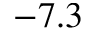<formula> <loc_0><loc_0><loc_500><loc_500>- 7 . 3</formula> 